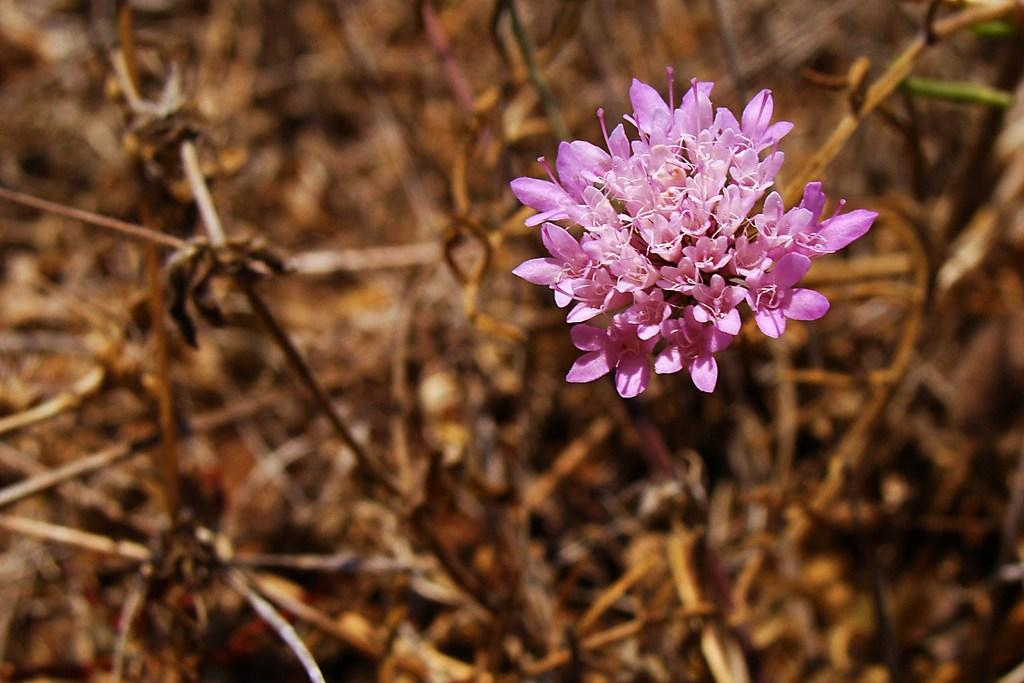What type of flowers are present in the image? There are pink color flowers in the image. How would you describe the appearance of the background in the image? The background is blurred. What color is the background in the image? The background color is brown. What type of calculator can be seen in the image? There is no calculator present in the image. What role does the parent play in the image? There is no parent or any human figure present in the image. 